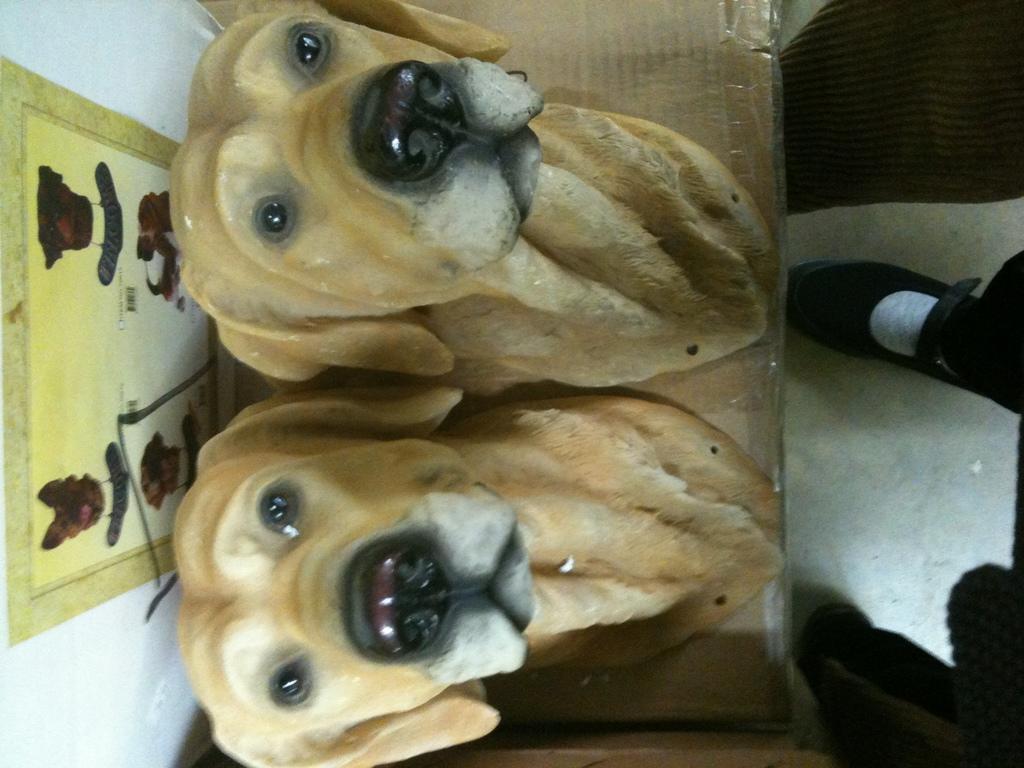How would you summarize this image in a sentence or two? This picture is clicked inside. On the right corner we can see the leg of a person. In the center we can see the sculptures of dogs placed on an object. In the background there is a picture frame hanging on the wall and there are some other objects. 